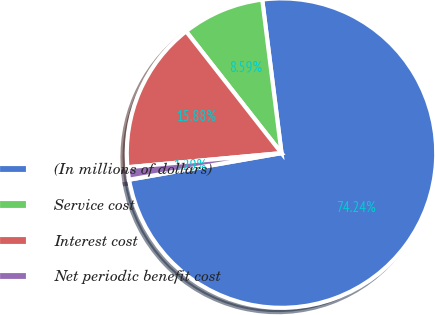Convert chart to OTSL. <chart><loc_0><loc_0><loc_500><loc_500><pie_chart><fcel>(In millions of dollars)<fcel>Service cost<fcel>Interest cost<fcel>Net periodic benefit cost<nl><fcel>74.24%<fcel>8.59%<fcel>15.88%<fcel>1.29%<nl></chart> 